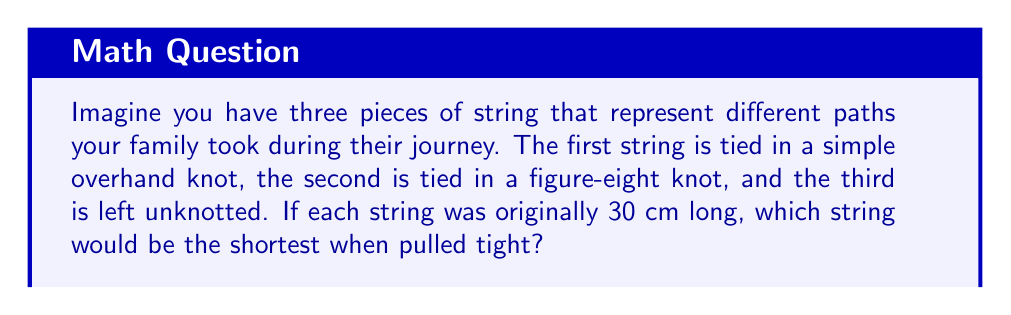Can you answer this question? Let's think about this step-by-step:

1. The unknotted string:
   This string remains 30 cm long as it has no knot.

2. The overhand knot:
   An overhand knot typically shortens a string by about 10-15% of its original length.
   Let's use 12% for our calculation:
   $30 \text{ cm} - (30 \text{ cm} \times 0.12) = 30 \text{ cm} - 3.6 \text{ cm} = 26.4 \text{ cm}$

3. The figure-eight knot:
   A figure-eight knot usually shortens a string by about 20-25% of its original length.
   Let's use 22% for our calculation:
   $30 \text{ cm} - (30 \text{ cm} \times 0.22) = 30 \text{ cm} - 6.6 \text{ cm} = 23.4 \text{ cm}$

Comparing the lengths:
- Unknotted string: 30 cm
- Overhand knot: 26.4 cm
- Figure-eight knot: 23.4 cm

The figure-eight knot results in the shortest string when pulled tight.
Answer: The string with the figure-eight knot (23.4 cm) 